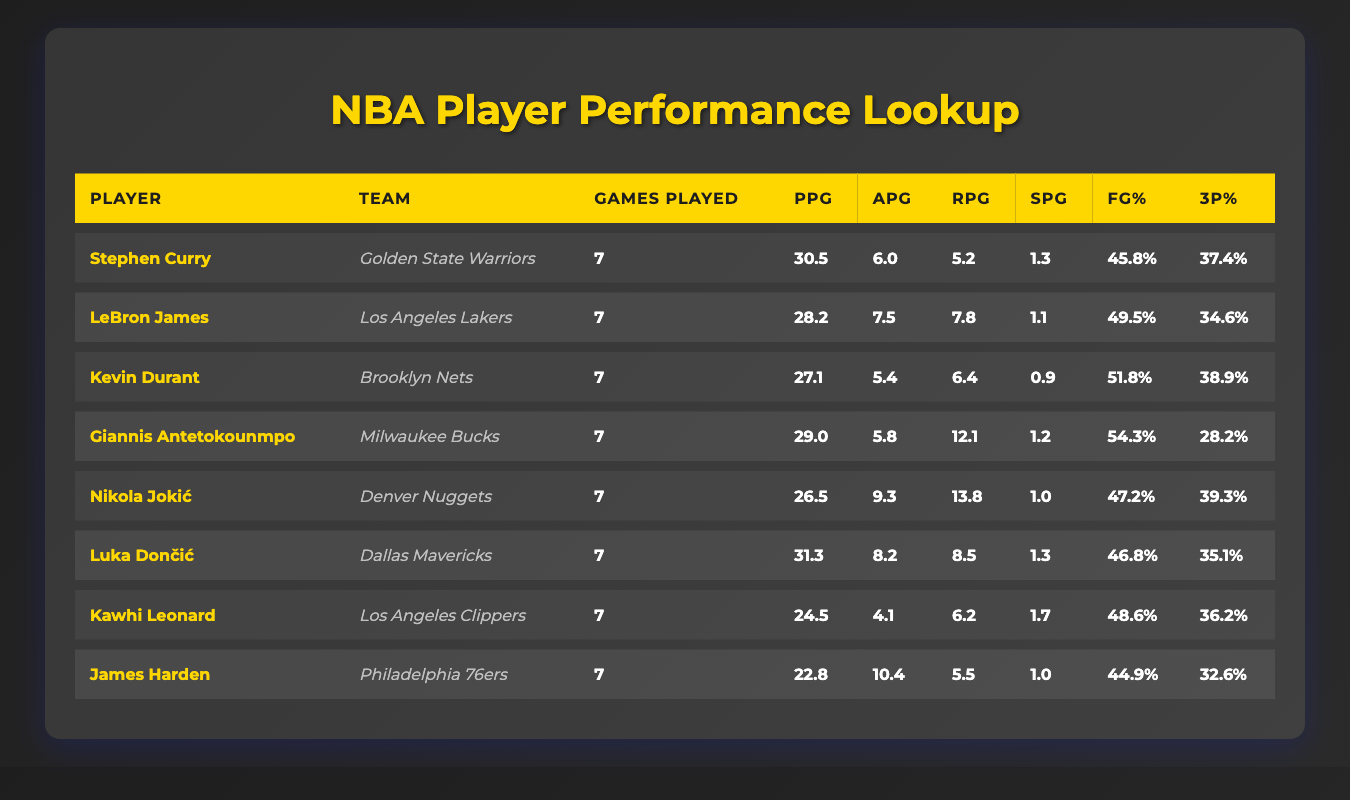What is the Points Per Game of Luka Dončić? The table specifies that Luka Dončić has a Points Per Game (PPG) of 31.3. This value can be directly retrieved from the corresponding row for Luka Dončić in the table.
Answer: 31.3 Which player has the highest Field Goal Percentage? By comparing the Field Goal Percentage (FG%) of all players, we see that Kevin Durant has the highest FG% at 51.8, listed in his row within the table.
Answer: Kevin Durant How many rebounds does Giannis Antetokounmpo average per game? The table indicates that Giannis Antetokounmpo has an average of 12.1 rebounds per game, which can be found directly in his performance data.
Answer: 12.1 What is the average Points Per Game (PPG) of the players listed? To find the average PPG, first sum the individual PPG values: 30.5 + 28.2 + 27.1 + 29.0 + 26.5 + 31.3 + 24.5 + 22.8 =  219.4. Then, divide by the number of players, which is 8. Thus, the average is 219.4 / 8 = 27.43.
Answer: 27.43 Is LeBron James' average assists per game greater than 7? According to the table, LeBron James has an average of 7.5 assists per game. Since 7.5 is greater than 7, the answer to the question is yes.
Answer: Yes Which player has the lowest Three Point Percentage? Reviewing the column for Three Point Percentage (3P%), we can see that Giannis Antetokounmpo has the lowest percentage at 28.2%. This value is listed in his row in the table.
Answer: Giannis Antetokounmpo How many total assists did James Harden register? James Harden's assists per game are listed as 10.4. Over 7 games, we calculate the total assists by multiplying 10.4 by 7. Thus, 10.4 * 7 = 72.8, concluding that James Harden has approximately 73 assists.
Answer: Approximately 73 What is the difference between points per game of Stephen Curry and Kevin Durant? To find the difference in PPG between Stephen Curry and Kevin Durant, subtract Kevin Durant's PPG of 27.1 from Stephen Curry's PPG of 30.5. Therefore, 30.5 - 27.1 = 3.4.
Answer: 3.4 